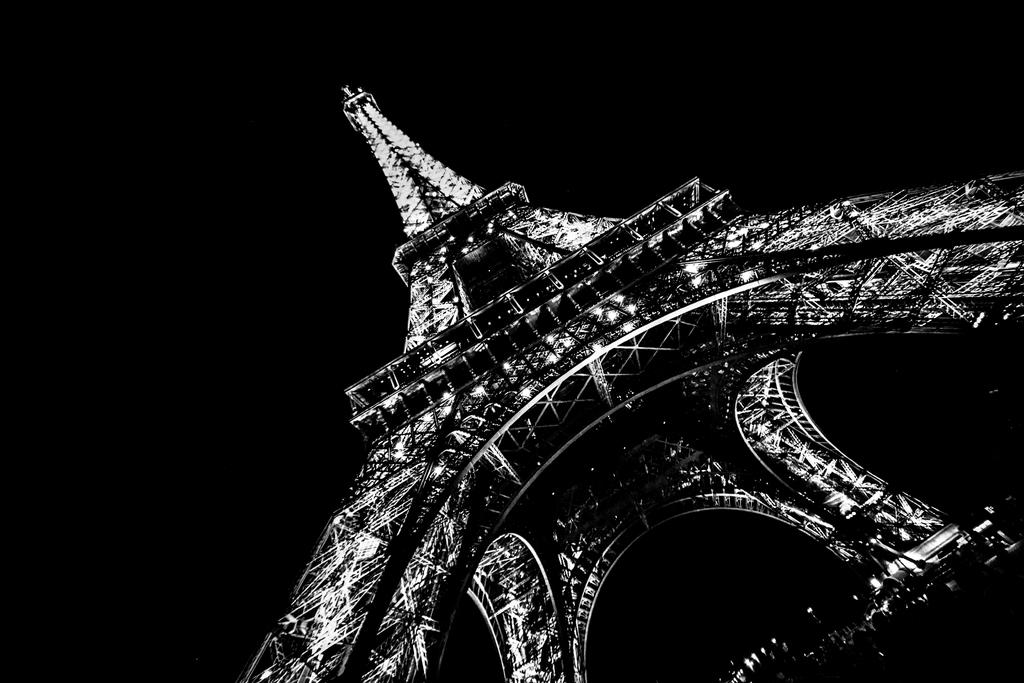What is the main subject of the image? The main subject of the image is the Eiffel tower. What can be observed about the background of the image? The background of the image is dark. What type of animals can be seen in the zoo in the image? There is no zoo present in the image, and therefore no animals can be observed. What type of drug can be seen in the image? There is no drug present in the image. What type of meeting is taking place in the image? There is no meeting present in the image. 